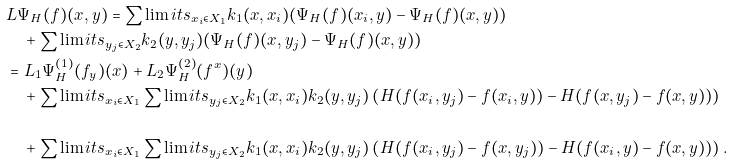<formula> <loc_0><loc_0><loc_500><loc_500>& L \Psi _ { H } ( f ) ( x , y ) = \sum \lim i t s _ { x _ { i } \in X _ { 1 } } k _ { 1 } ( x , x _ { i } ) ( \Psi _ { H } ( f ) ( x _ { i } , y ) - \Psi _ { H } ( f ) ( x , y ) ) \\ & \quad + \sum \lim i t s _ { y _ { j } \in X _ { 2 } } k _ { 2 } ( y , y _ { j } ) ( \Psi _ { H } ( f ) ( x , y _ { j } ) - \Psi _ { H } ( f ) ( x , y ) ) \\ & = L _ { 1 } \Psi _ { H } ^ { ( 1 ) } ( f _ { y } ) ( x ) + L _ { 2 } \Psi _ { H } ^ { ( 2 ) } ( f ^ { x } ) ( y ) \\ & \quad + \sum \lim i t s _ { x _ { i } \in X _ { 1 } } \sum \lim i t s _ { y _ { j } \in X _ { 2 } } k _ { 1 } ( x , x _ { i } ) k _ { 2 } ( y , y _ { j } ) \left ( H ( f ( x _ { i } , y _ { j } ) - f ( x _ { i } , y ) ) - H ( f ( x , y _ { j } ) - f ( x , y ) ) \right ) \\ \\ & \quad + \sum \lim i t s _ { x _ { i } \in X _ { 1 } } \sum \lim i t s _ { y _ { j } \in X _ { 2 } } k _ { 1 } ( x , x _ { i } ) k _ { 2 } ( y , y _ { j } ) \left ( H ( f ( x _ { i } , y _ { j } ) - f ( x , y _ { j } ) ) - H ( f ( x _ { i } , y ) - f ( x , y ) ) \right ) .</formula> 